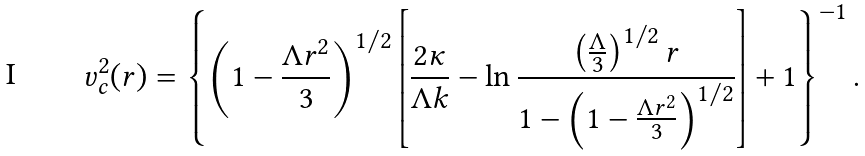<formula> <loc_0><loc_0><loc_500><loc_500>v _ { c } ^ { 2 } ( r ) = \left \{ \left ( 1 - \frac { \Lambda r ^ { 2 } } { 3 } \right ) ^ { 1 / 2 } \left [ \frac { 2 \kappa } { \Lambda k } - \ln { \frac { \left ( \frac { \Lambda } { 3 } \right ) ^ { 1 / 2 } r } { 1 - \left ( 1 - \frac { \Lambda r ^ { 2 } } { 3 } \right ) ^ { 1 / 2 } } } \right ] + 1 \right \} ^ { - 1 } .</formula> 